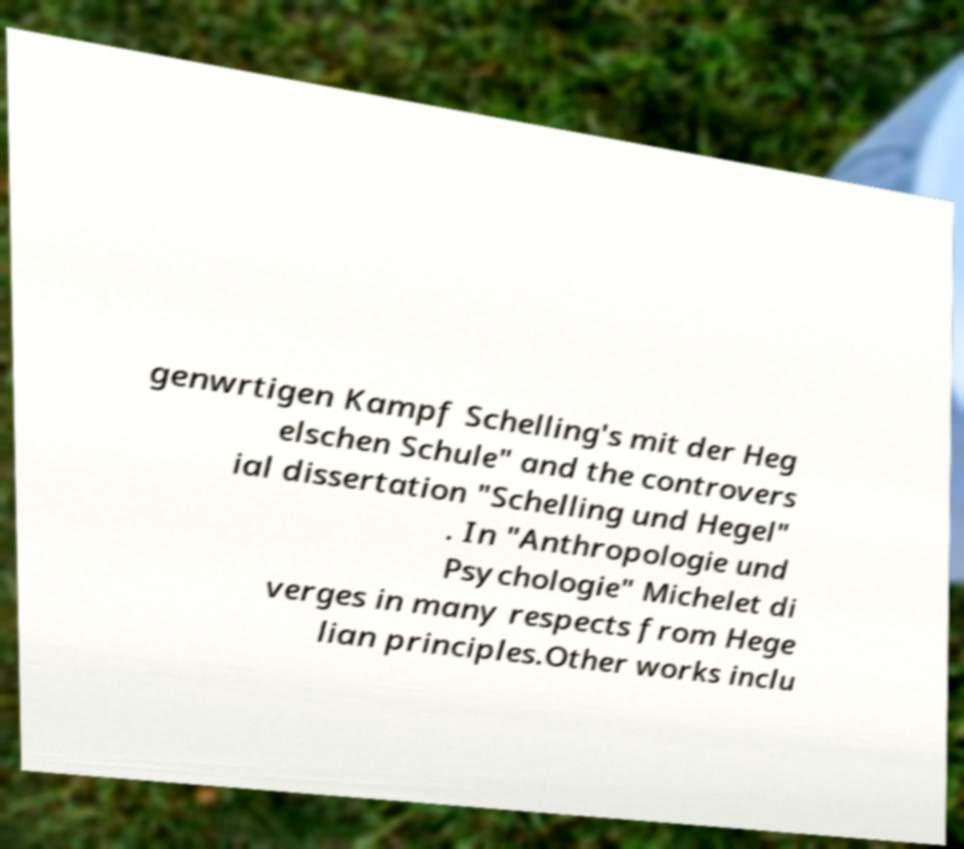I need the written content from this picture converted into text. Can you do that? genwrtigen Kampf Schelling's mit der Heg elschen Schule" and the controvers ial dissertation "Schelling und Hegel" . In "Anthropologie und Psychologie" Michelet di verges in many respects from Hege lian principles.Other works inclu 